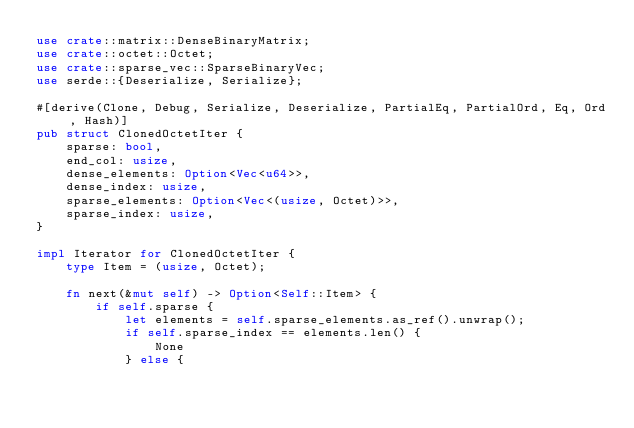Convert code to text. <code><loc_0><loc_0><loc_500><loc_500><_Rust_>use crate::matrix::DenseBinaryMatrix;
use crate::octet::Octet;
use crate::sparse_vec::SparseBinaryVec;
use serde::{Deserialize, Serialize};

#[derive(Clone, Debug, Serialize, Deserialize, PartialEq, PartialOrd, Eq, Ord, Hash)]
pub struct ClonedOctetIter {
    sparse: bool,
    end_col: usize,
    dense_elements: Option<Vec<u64>>,
    dense_index: usize,
    sparse_elements: Option<Vec<(usize, Octet)>>,
    sparse_index: usize,
}

impl Iterator for ClonedOctetIter {
    type Item = (usize, Octet);

    fn next(&mut self) -> Option<Self::Item> {
        if self.sparse {
            let elements = self.sparse_elements.as_ref().unwrap();
            if self.sparse_index == elements.len() {
                None
            } else {</code> 